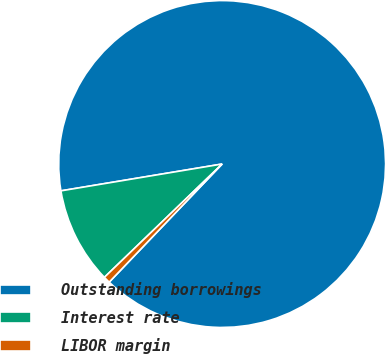Convert chart. <chart><loc_0><loc_0><loc_500><loc_500><pie_chart><fcel>Outstanding borrowings<fcel>Interest rate<fcel>LIBOR margin<nl><fcel>89.77%<fcel>9.57%<fcel>0.66%<nl></chart> 